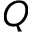Convert formula to latex. <formula><loc_0><loc_0><loc_500><loc_500>Q</formula> 